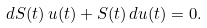<formula> <loc_0><loc_0><loc_500><loc_500>d S ( t ) \, u ( t ) + S ( t ) \, d u ( t ) = 0 .</formula> 